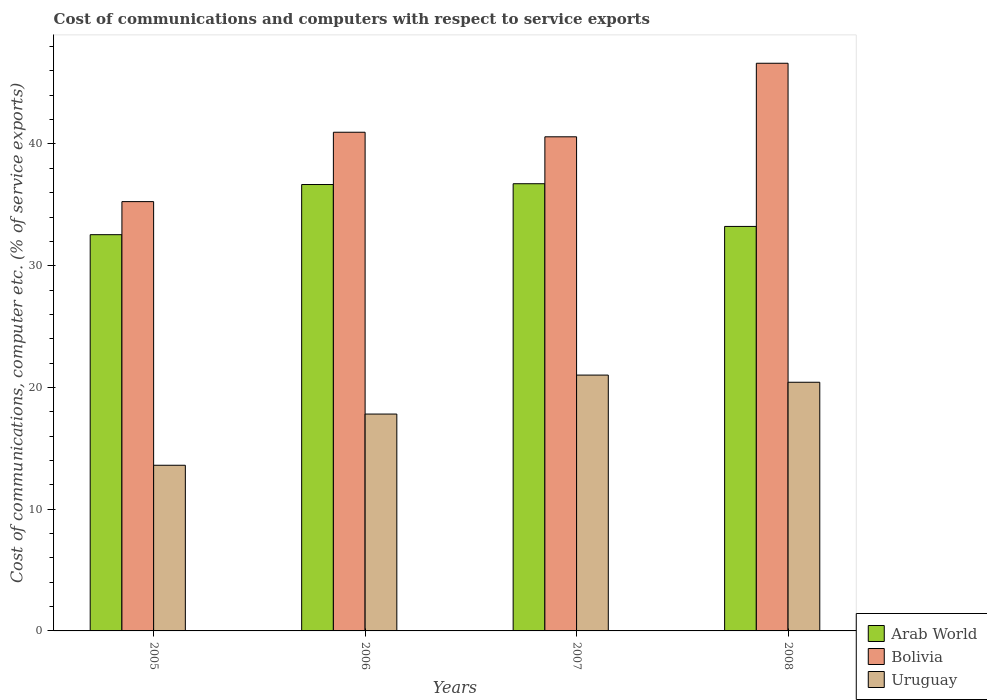Are the number of bars per tick equal to the number of legend labels?
Provide a short and direct response. Yes. How many bars are there on the 2nd tick from the left?
Your answer should be compact. 3. How many bars are there on the 3rd tick from the right?
Provide a short and direct response. 3. What is the label of the 2nd group of bars from the left?
Ensure brevity in your answer.  2006. What is the cost of communications and computers in Arab World in 2006?
Give a very brief answer. 36.67. Across all years, what is the maximum cost of communications and computers in Bolivia?
Offer a very short reply. 46.63. Across all years, what is the minimum cost of communications and computers in Arab World?
Ensure brevity in your answer.  32.55. In which year was the cost of communications and computers in Bolivia maximum?
Provide a short and direct response. 2008. What is the total cost of communications and computers in Arab World in the graph?
Provide a short and direct response. 139.18. What is the difference between the cost of communications and computers in Uruguay in 2005 and that in 2007?
Offer a terse response. -7.41. What is the difference between the cost of communications and computers in Arab World in 2008 and the cost of communications and computers in Uruguay in 2007?
Your answer should be compact. 12.21. What is the average cost of communications and computers in Bolivia per year?
Your answer should be very brief. 40.86. In the year 2008, what is the difference between the cost of communications and computers in Arab World and cost of communications and computers in Bolivia?
Your answer should be very brief. -13.4. What is the ratio of the cost of communications and computers in Uruguay in 2006 to that in 2007?
Your answer should be compact. 0.85. Is the difference between the cost of communications and computers in Arab World in 2006 and 2007 greater than the difference between the cost of communications and computers in Bolivia in 2006 and 2007?
Keep it short and to the point. No. What is the difference between the highest and the second highest cost of communications and computers in Bolivia?
Give a very brief answer. 5.67. What is the difference between the highest and the lowest cost of communications and computers in Uruguay?
Offer a terse response. 7.41. Is the sum of the cost of communications and computers in Uruguay in 2005 and 2007 greater than the maximum cost of communications and computers in Arab World across all years?
Your answer should be very brief. No. What does the 1st bar from the left in 2005 represents?
Give a very brief answer. Arab World. What does the 1st bar from the right in 2008 represents?
Offer a very short reply. Uruguay. Are the values on the major ticks of Y-axis written in scientific E-notation?
Your answer should be compact. No. Does the graph contain any zero values?
Provide a short and direct response. No. Does the graph contain grids?
Your answer should be very brief. No. What is the title of the graph?
Give a very brief answer. Cost of communications and computers with respect to service exports. What is the label or title of the Y-axis?
Make the answer very short. Cost of communications, computer etc. (% of service exports). What is the Cost of communications, computer etc. (% of service exports) in Arab World in 2005?
Offer a very short reply. 32.55. What is the Cost of communications, computer etc. (% of service exports) of Bolivia in 2005?
Offer a terse response. 35.26. What is the Cost of communications, computer etc. (% of service exports) in Uruguay in 2005?
Your response must be concise. 13.61. What is the Cost of communications, computer etc. (% of service exports) of Arab World in 2006?
Your answer should be compact. 36.67. What is the Cost of communications, computer etc. (% of service exports) in Bolivia in 2006?
Provide a succinct answer. 40.96. What is the Cost of communications, computer etc. (% of service exports) in Uruguay in 2006?
Ensure brevity in your answer.  17.81. What is the Cost of communications, computer etc. (% of service exports) in Arab World in 2007?
Offer a terse response. 36.73. What is the Cost of communications, computer etc. (% of service exports) in Bolivia in 2007?
Offer a very short reply. 40.59. What is the Cost of communications, computer etc. (% of service exports) in Uruguay in 2007?
Make the answer very short. 21.01. What is the Cost of communications, computer etc. (% of service exports) in Arab World in 2008?
Provide a succinct answer. 33.23. What is the Cost of communications, computer etc. (% of service exports) of Bolivia in 2008?
Offer a very short reply. 46.63. What is the Cost of communications, computer etc. (% of service exports) in Uruguay in 2008?
Provide a succinct answer. 20.43. Across all years, what is the maximum Cost of communications, computer etc. (% of service exports) of Arab World?
Your answer should be very brief. 36.73. Across all years, what is the maximum Cost of communications, computer etc. (% of service exports) of Bolivia?
Ensure brevity in your answer.  46.63. Across all years, what is the maximum Cost of communications, computer etc. (% of service exports) in Uruguay?
Your answer should be very brief. 21.01. Across all years, what is the minimum Cost of communications, computer etc. (% of service exports) of Arab World?
Offer a very short reply. 32.55. Across all years, what is the minimum Cost of communications, computer etc. (% of service exports) in Bolivia?
Keep it short and to the point. 35.26. Across all years, what is the minimum Cost of communications, computer etc. (% of service exports) of Uruguay?
Give a very brief answer. 13.61. What is the total Cost of communications, computer etc. (% of service exports) of Arab World in the graph?
Give a very brief answer. 139.18. What is the total Cost of communications, computer etc. (% of service exports) in Bolivia in the graph?
Give a very brief answer. 163.44. What is the total Cost of communications, computer etc. (% of service exports) in Uruguay in the graph?
Make the answer very short. 72.86. What is the difference between the Cost of communications, computer etc. (% of service exports) in Arab World in 2005 and that in 2006?
Offer a terse response. -4.12. What is the difference between the Cost of communications, computer etc. (% of service exports) of Bolivia in 2005 and that in 2006?
Provide a short and direct response. -5.7. What is the difference between the Cost of communications, computer etc. (% of service exports) in Uruguay in 2005 and that in 2006?
Provide a succinct answer. -4.21. What is the difference between the Cost of communications, computer etc. (% of service exports) of Arab World in 2005 and that in 2007?
Offer a terse response. -4.19. What is the difference between the Cost of communications, computer etc. (% of service exports) in Bolivia in 2005 and that in 2007?
Give a very brief answer. -5.32. What is the difference between the Cost of communications, computer etc. (% of service exports) in Uruguay in 2005 and that in 2007?
Provide a short and direct response. -7.41. What is the difference between the Cost of communications, computer etc. (% of service exports) of Arab World in 2005 and that in 2008?
Your answer should be very brief. -0.68. What is the difference between the Cost of communications, computer etc. (% of service exports) in Bolivia in 2005 and that in 2008?
Give a very brief answer. -11.36. What is the difference between the Cost of communications, computer etc. (% of service exports) in Uruguay in 2005 and that in 2008?
Your response must be concise. -6.82. What is the difference between the Cost of communications, computer etc. (% of service exports) in Arab World in 2006 and that in 2007?
Give a very brief answer. -0.06. What is the difference between the Cost of communications, computer etc. (% of service exports) in Bolivia in 2006 and that in 2007?
Your answer should be compact. 0.37. What is the difference between the Cost of communications, computer etc. (% of service exports) in Uruguay in 2006 and that in 2007?
Your answer should be very brief. -3.2. What is the difference between the Cost of communications, computer etc. (% of service exports) of Arab World in 2006 and that in 2008?
Your response must be concise. 3.44. What is the difference between the Cost of communications, computer etc. (% of service exports) of Bolivia in 2006 and that in 2008?
Provide a short and direct response. -5.67. What is the difference between the Cost of communications, computer etc. (% of service exports) in Uruguay in 2006 and that in 2008?
Give a very brief answer. -2.61. What is the difference between the Cost of communications, computer etc. (% of service exports) in Arab World in 2007 and that in 2008?
Ensure brevity in your answer.  3.51. What is the difference between the Cost of communications, computer etc. (% of service exports) in Bolivia in 2007 and that in 2008?
Provide a succinct answer. -6.04. What is the difference between the Cost of communications, computer etc. (% of service exports) in Uruguay in 2007 and that in 2008?
Your answer should be compact. 0.59. What is the difference between the Cost of communications, computer etc. (% of service exports) of Arab World in 2005 and the Cost of communications, computer etc. (% of service exports) of Bolivia in 2006?
Offer a very short reply. -8.41. What is the difference between the Cost of communications, computer etc. (% of service exports) in Arab World in 2005 and the Cost of communications, computer etc. (% of service exports) in Uruguay in 2006?
Provide a short and direct response. 14.73. What is the difference between the Cost of communications, computer etc. (% of service exports) in Bolivia in 2005 and the Cost of communications, computer etc. (% of service exports) in Uruguay in 2006?
Keep it short and to the point. 17.45. What is the difference between the Cost of communications, computer etc. (% of service exports) in Arab World in 2005 and the Cost of communications, computer etc. (% of service exports) in Bolivia in 2007?
Ensure brevity in your answer.  -8.04. What is the difference between the Cost of communications, computer etc. (% of service exports) in Arab World in 2005 and the Cost of communications, computer etc. (% of service exports) in Uruguay in 2007?
Your answer should be very brief. 11.53. What is the difference between the Cost of communications, computer etc. (% of service exports) of Bolivia in 2005 and the Cost of communications, computer etc. (% of service exports) of Uruguay in 2007?
Give a very brief answer. 14.25. What is the difference between the Cost of communications, computer etc. (% of service exports) of Arab World in 2005 and the Cost of communications, computer etc. (% of service exports) of Bolivia in 2008?
Your response must be concise. -14.08. What is the difference between the Cost of communications, computer etc. (% of service exports) in Arab World in 2005 and the Cost of communications, computer etc. (% of service exports) in Uruguay in 2008?
Your answer should be compact. 12.12. What is the difference between the Cost of communications, computer etc. (% of service exports) of Bolivia in 2005 and the Cost of communications, computer etc. (% of service exports) of Uruguay in 2008?
Make the answer very short. 14.84. What is the difference between the Cost of communications, computer etc. (% of service exports) in Arab World in 2006 and the Cost of communications, computer etc. (% of service exports) in Bolivia in 2007?
Your response must be concise. -3.92. What is the difference between the Cost of communications, computer etc. (% of service exports) in Arab World in 2006 and the Cost of communications, computer etc. (% of service exports) in Uruguay in 2007?
Offer a very short reply. 15.65. What is the difference between the Cost of communications, computer etc. (% of service exports) in Bolivia in 2006 and the Cost of communications, computer etc. (% of service exports) in Uruguay in 2007?
Your answer should be compact. 19.95. What is the difference between the Cost of communications, computer etc. (% of service exports) in Arab World in 2006 and the Cost of communications, computer etc. (% of service exports) in Bolivia in 2008?
Your answer should be very brief. -9.96. What is the difference between the Cost of communications, computer etc. (% of service exports) in Arab World in 2006 and the Cost of communications, computer etc. (% of service exports) in Uruguay in 2008?
Provide a short and direct response. 16.24. What is the difference between the Cost of communications, computer etc. (% of service exports) of Bolivia in 2006 and the Cost of communications, computer etc. (% of service exports) of Uruguay in 2008?
Your answer should be compact. 20.54. What is the difference between the Cost of communications, computer etc. (% of service exports) of Arab World in 2007 and the Cost of communications, computer etc. (% of service exports) of Bolivia in 2008?
Provide a short and direct response. -9.9. What is the difference between the Cost of communications, computer etc. (% of service exports) in Arab World in 2007 and the Cost of communications, computer etc. (% of service exports) in Uruguay in 2008?
Offer a very short reply. 16.31. What is the difference between the Cost of communications, computer etc. (% of service exports) of Bolivia in 2007 and the Cost of communications, computer etc. (% of service exports) of Uruguay in 2008?
Your response must be concise. 20.16. What is the average Cost of communications, computer etc. (% of service exports) in Arab World per year?
Provide a succinct answer. 34.79. What is the average Cost of communications, computer etc. (% of service exports) in Bolivia per year?
Keep it short and to the point. 40.86. What is the average Cost of communications, computer etc. (% of service exports) in Uruguay per year?
Keep it short and to the point. 18.22. In the year 2005, what is the difference between the Cost of communications, computer etc. (% of service exports) in Arab World and Cost of communications, computer etc. (% of service exports) in Bolivia?
Make the answer very short. -2.72. In the year 2005, what is the difference between the Cost of communications, computer etc. (% of service exports) in Arab World and Cost of communications, computer etc. (% of service exports) in Uruguay?
Keep it short and to the point. 18.94. In the year 2005, what is the difference between the Cost of communications, computer etc. (% of service exports) of Bolivia and Cost of communications, computer etc. (% of service exports) of Uruguay?
Your response must be concise. 21.66. In the year 2006, what is the difference between the Cost of communications, computer etc. (% of service exports) of Arab World and Cost of communications, computer etc. (% of service exports) of Bolivia?
Provide a short and direct response. -4.29. In the year 2006, what is the difference between the Cost of communications, computer etc. (% of service exports) in Arab World and Cost of communications, computer etc. (% of service exports) in Uruguay?
Your answer should be very brief. 18.85. In the year 2006, what is the difference between the Cost of communications, computer etc. (% of service exports) in Bolivia and Cost of communications, computer etc. (% of service exports) in Uruguay?
Offer a very short reply. 23.15. In the year 2007, what is the difference between the Cost of communications, computer etc. (% of service exports) of Arab World and Cost of communications, computer etc. (% of service exports) of Bolivia?
Make the answer very short. -3.85. In the year 2007, what is the difference between the Cost of communications, computer etc. (% of service exports) in Arab World and Cost of communications, computer etc. (% of service exports) in Uruguay?
Your answer should be very brief. 15.72. In the year 2007, what is the difference between the Cost of communications, computer etc. (% of service exports) in Bolivia and Cost of communications, computer etc. (% of service exports) in Uruguay?
Ensure brevity in your answer.  19.57. In the year 2008, what is the difference between the Cost of communications, computer etc. (% of service exports) of Arab World and Cost of communications, computer etc. (% of service exports) of Bolivia?
Ensure brevity in your answer.  -13.4. In the year 2008, what is the difference between the Cost of communications, computer etc. (% of service exports) in Arab World and Cost of communications, computer etc. (% of service exports) in Uruguay?
Your answer should be very brief. 12.8. In the year 2008, what is the difference between the Cost of communications, computer etc. (% of service exports) in Bolivia and Cost of communications, computer etc. (% of service exports) in Uruguay?
Keep it short and to the point. 26.2. What is the ratio of the Cost of communications, computer etc. (% of service exports) in Arab World in 2005 to that in 2006?
Make the answer very short. 0.89. What is the ratio of the Cost of communications, computer etc. (% of service exports) of Bolivia in 2005 to that in 2006?
Give a very brief answer. 0.86. What is the ratio of the Cost of communications, computer etc. (% of service exports) in Uruguay in 2005 to that in 2006?
Make the answer very short. 0.76. What is the ratio of the Cost of communications, computer etc. (% of service exports) in Arab World in 2005 to that in 2007?
Your answer should be compact. 0.89. What is the ratio of the Cost of communications, computer etc. (% of service exports) in Bolivia in 2005 to that in 2007?
Offer a terse response. 0.87. What is the ratio of the Cost of communications, computer etc. (% of service exports) of Uruguay in 2005 to that in 2007?
Provide a succinct answer. 0.65. What is the ratio of the Cost of communications, computer etc. (% of service exports) in Arab World in 2005 to that in 2008?
Offer a very short reply. 0.98. What is the ratio of the Cost of communications, computer etc. (% of service exports) in Bolivia in 2005 to that in 2008?
Offer a very short reply. 0.76. What is the ratio of the Cost of communications, computer etc. (% of service exports) in Uruguay in 2005 to that in 2008?
Make the answer very short. 0.67. What is the ratio of the Cost of communications, computer etc. (% of service exports) of Arab World in 2006 to that in 2007?
Your response must be concise. 1. What is the ratio of the Cost of communications, computer etc. (% of service exports) in Bolivia in 2006 to that in 2007?
Your answer should be very brief. 1.01. What is the ratio of the Cost of communications, computer etc. (% of service exports) in Uruguay in 2006 to that in 2007?
Your answer should be very brief. 0.85. What is the ratio of the Cost of communications, computer etc. (% of service exports) of Arab World in 2006 to that in 2008?
Your answer should be very brief. 1.1. What is the ratio of the Cost of communications, computer etc. (% of service exports) of Bolivia in 2006 to that in 2008?
Your answer should be very brief. 0.88. What is the ratio of the Cost of communications, computer etc. (% of service exports) of Uruguay in 2006 to that in 2008?
Make the answer very short. 0.87. What is the ratio of the Cost of communications, computer etc. (% of service exports) in Arab World in 2007 to that in 2008?
Offer a terse response. 1.11. What is the ratio of the Cost of communications, computer etc. (% of service exports) of Bolivia in 2007 to that in 2008?
Your answer should be very brief. 0.87. What is the ratio of the Cost of communications, computer etc. (% of service exports) in Uruguay in 2007 to that in 2008?
Offer a very short reply. 1.03. What is the difference between the highest and the second highest Cost of communications, computer etc. (% of service exports) of Arab World?
Provide a succinct answer. 0.06. What is the difference between the highest and the second highest Cost of communications, computer etc. (% of service exports) of Bolivia?
Provide a succinct answer. 5.67. What is the difference between the highest and the second highest Cost of communications, computer etc. (% of service exports) of Uruguay?
Ensure brevity in your answer.  0.59. What is the difference between the highest and the lowest Cost of communications, computer etc. (% of service exports) in Arab World?
Ensure brevity in your answer.  4.19. What is the difference between the highest and the lowest Cost of communications, computer etc. (% of service exports) in Bolivia?
Your response must be concise. 11.36. What is the difference between the highest and the lowest Cost of communications, computer etc. (% of service exports) of Uruguay?
Keep it short and to the point. 7.41. 